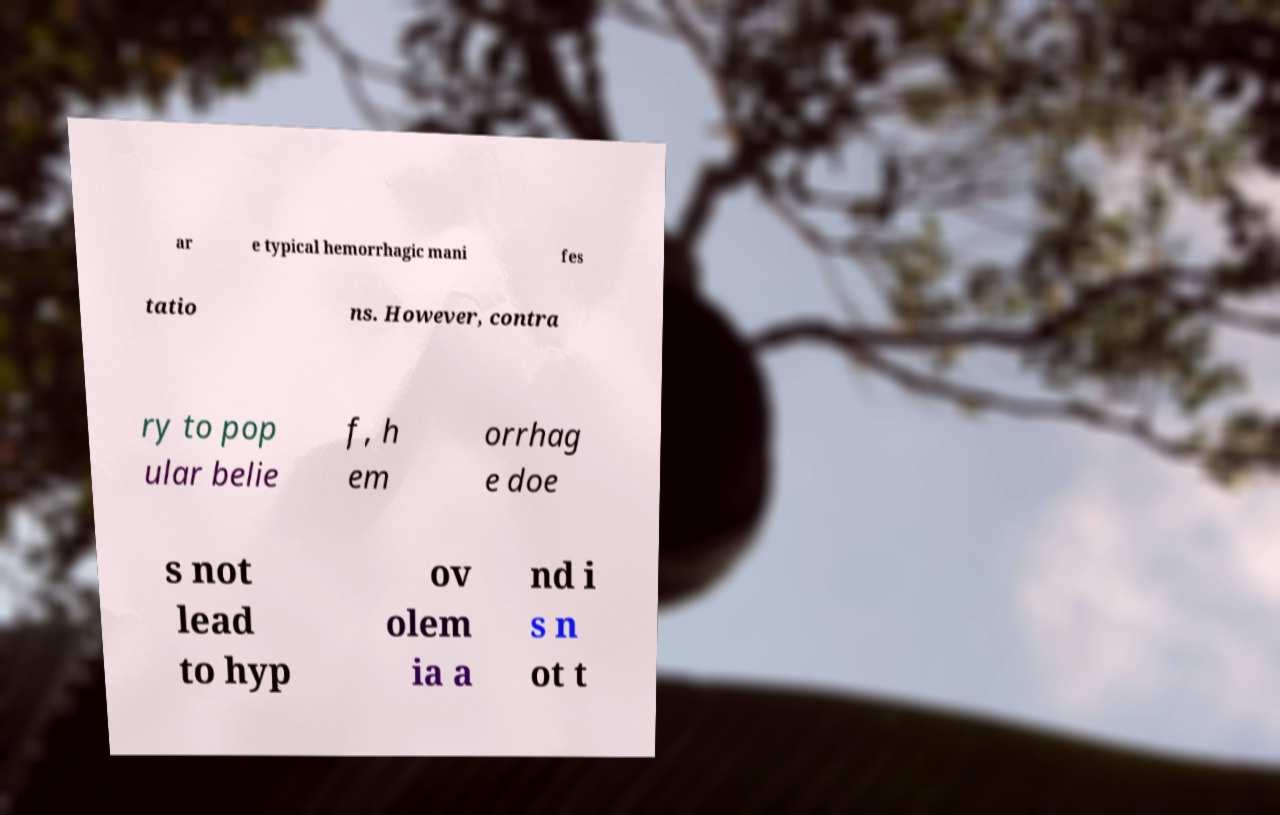Can you accurately transcribe the text from the provided image for me? ar e typical hemorrhagic mani fes tatio ns. However, contra ry to pop ular belie f, h em orrhag e doe s not lead to hyp ov olem ia a nd i s n ot t 